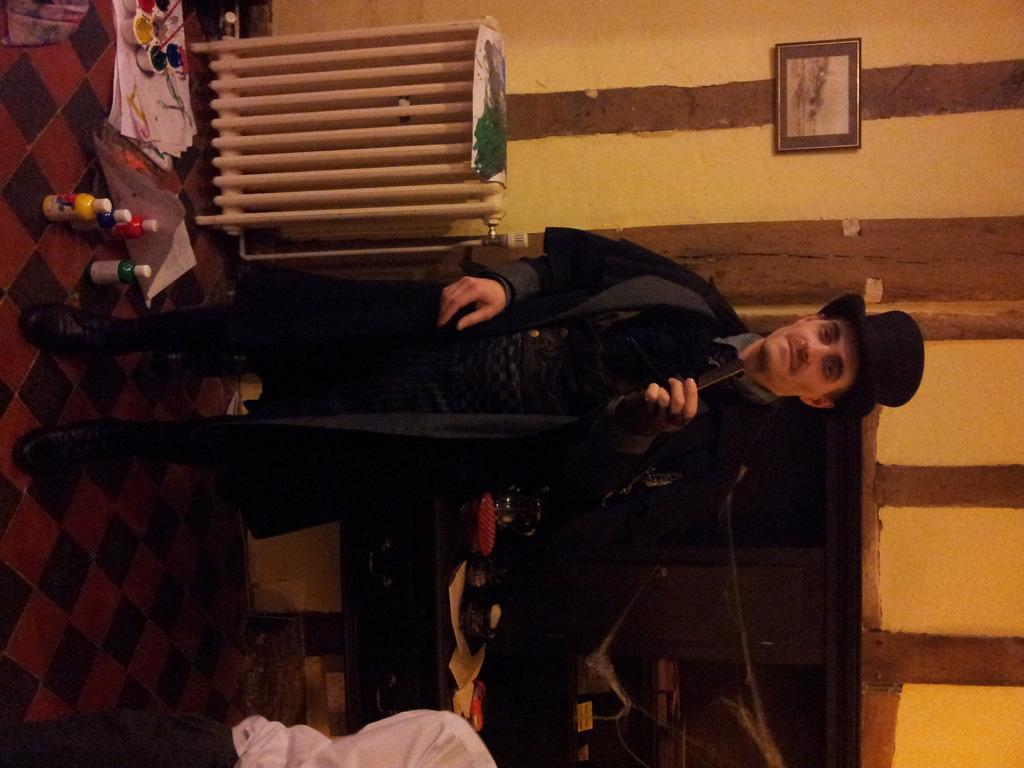Could you give a brief overview of what you see in this image? In the center picture there is a person standing, he is wearing a black suit. At the top there are wall, frame, paints, bottles and papers. At the bottom there are fireplace, papers, person, desk and other objects. 